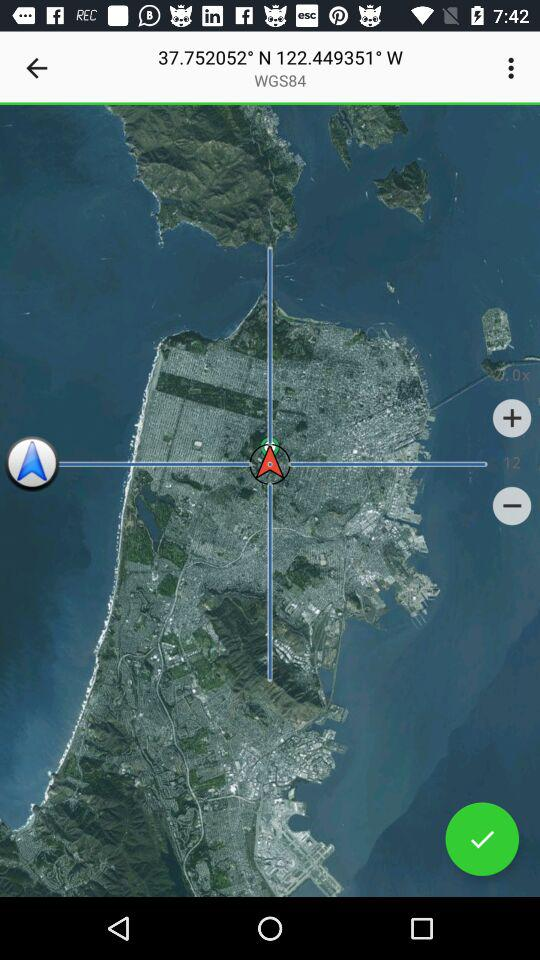How many degrees in north? It is 37.752052° in the north. 